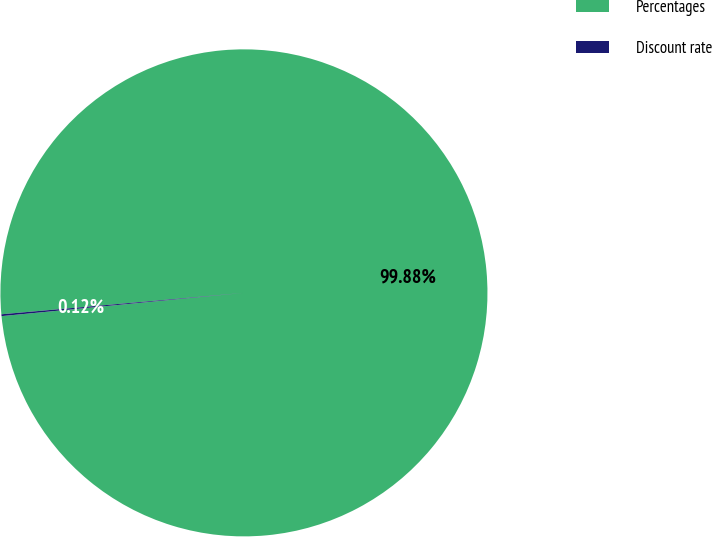Convert chart. <chart><loc_0><loc_0><loc_500><loc_500><pie_chart><fcel>Percentages<fcel>Discount rate<nl><fcel>99.88%<fcel>0.12%<nl></chart> 